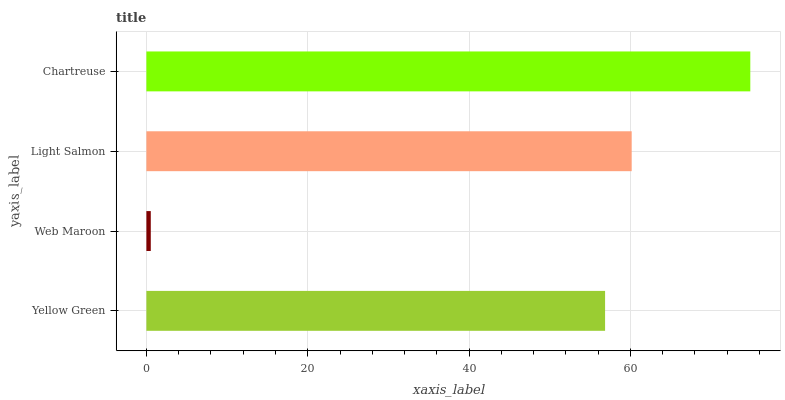Is Web Maroon the minimum?
Answer yes or no. Yes. Is Chartreuse the maximum?
Answer yes or no. Yes. Is Light Salmon the minimum?
Answer yes or no. No. Is Light Salmon the maximum?
Answer yes or no. No. Is Light Salmon greater than Web Maroon?
Answer yes or no. Yes. Is Web Maroon less than Light Salmon?
Answer yes or no. Yes. Is Web Maroon greater than Light Salmon?
Answer yes or no. No. Is Light Salmon less than Web Maroon?
Answer yes or no. No. Is Light Salmon the high median?
Answer yes or no. Yes. Is Yellow Green the low median?
Answer yes or no. Yes. Is Web Maroon the high median?
Answer yes or no. No. Is Chartreuse the low median?
Answer yes or no. No. 